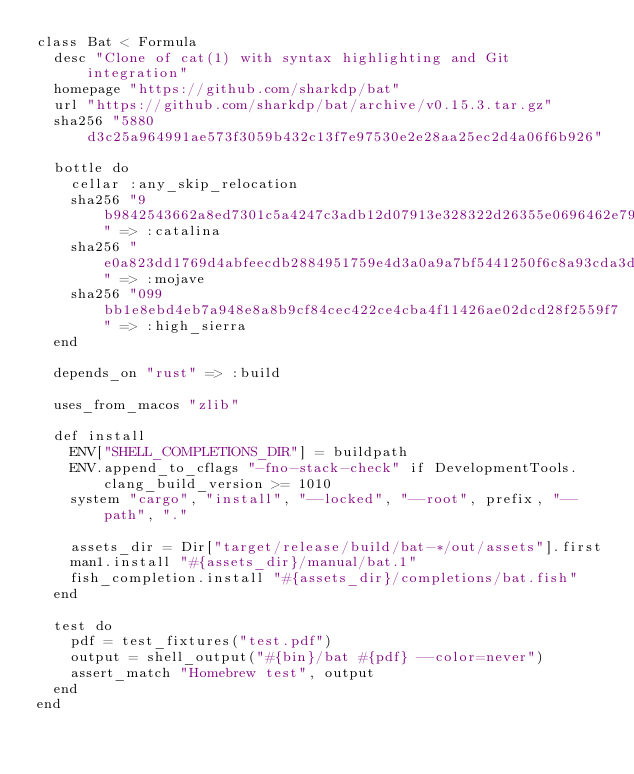Convert code to text. <code><loc_0><loc_0><loc_500><loc_500><_Ruby_>class Bat < Formula
  desc "Clone of cat(1) with syntax highlighting and Git integration"
  homepage "https://github.com/sharkdp/bat"
  url "https://github.com/sharkdp/bat/archive/v0.15.3.tar.gz"
  sha256 "5880d3c25a964991ae573f3059b432c13f7e97530e2e28aa25ec2d4a06f6b926"

  bottle do
    cellar :any_skip_relocation
    sha256 "9b9842543662a8ed7301c5a4247c3adb12d07913e328322d26355e0696462e79" => :catalina
    sha256 "e0a823dd1769d4abfeecdb2884951759e4d3a0a9a7bf5441250f6c8a93cda3d2" => :mojave
    sha256 "099bb1e8ebd4eb7a948e8a8b9cf84cec422ce4cba4f11426ae02dcd28f2559f7" => :high_sierra
  end

  depends_on "rust" => :build

  uses_from_macos "zlib"

  def install
    ENV["SHELL_COMPLETIONS_DIR"] = buildpath
    ENV.append_to_cflags "-fno-stack-check" if DevelopmentTools.clang_build_version >= 1010
    system "cargo", "install", "--locked", "--root", prefix, "--path", "."

    assets_dir = Dir["target/release/build/bat-*/out/assets"].first
    man1.install "#{assets_dir}/manual/bat.1"
    fish_completion.install "#{assets_dir}/completions/bat.fish"
  end

  test do
    pdf = test_fixtures("test.pdf")
    output = shell_output("#{bin}/bat #{pdf} --color=never")
    assert_match "Homebrew test", output
  end
end
</code> 